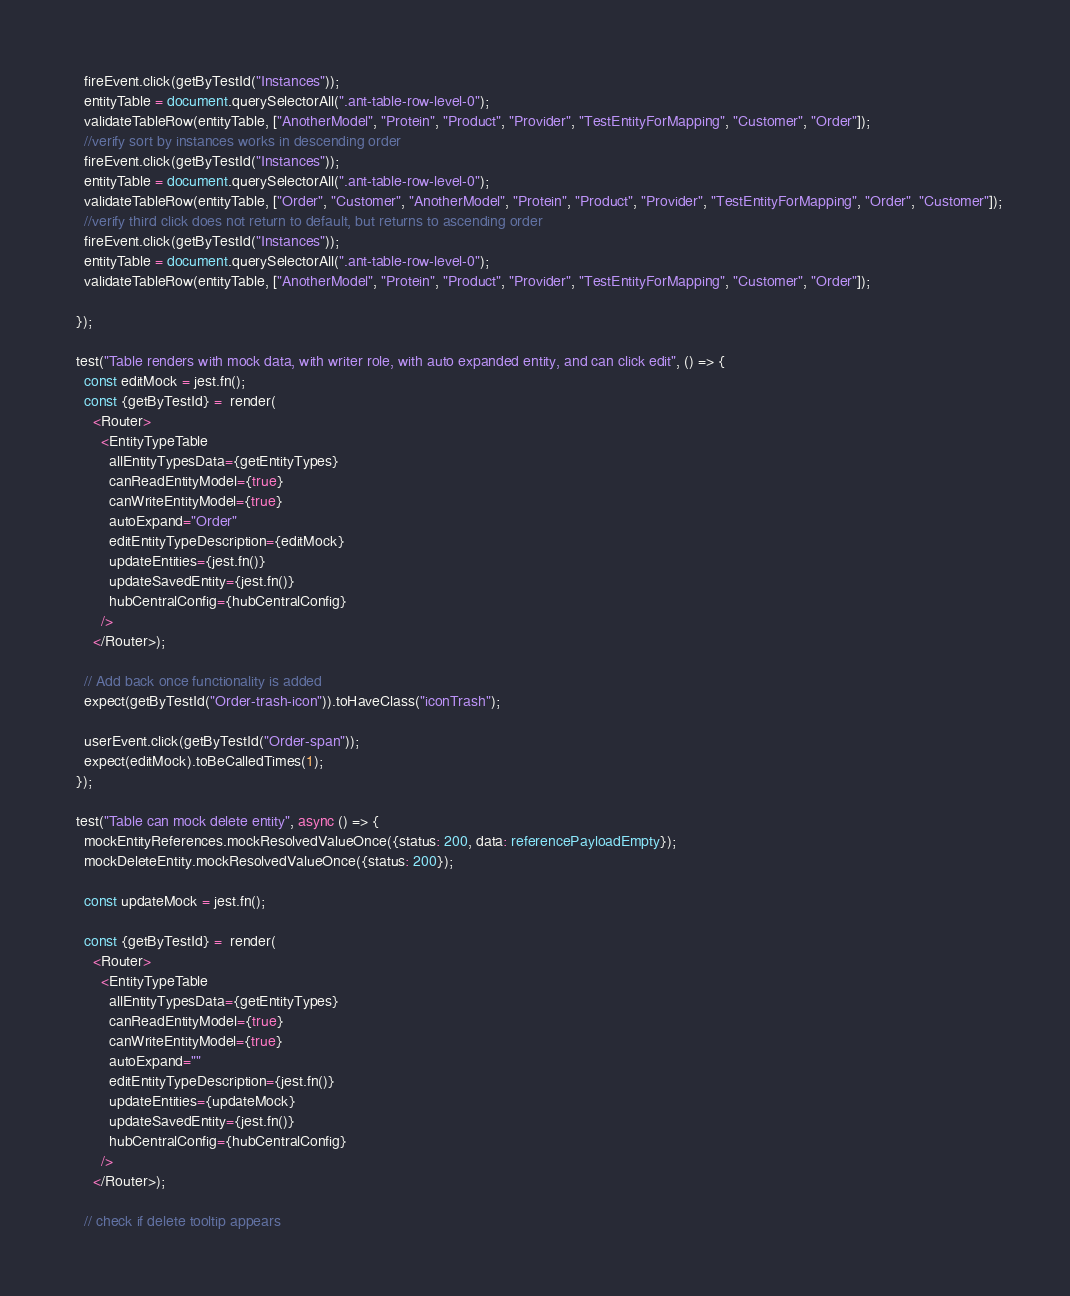<code> <loc_0><loc_0><loc_500><loc_500><_TypeScript_>    fireEvent.click(getByTestId("Instances"));
    entityTable = document.querySelectorAll(".ant-table-row-level-0");
    validateTableRow(entityTable, ["AnotherModel", "Protein", "Product", "Provider", "TestEntityForMapping", "Customer", "Order"]);
    //verify sort by instances works in descending order
    fireEvent.click(getByTestId("Instances"));
    entityTable = document.querySelectorAll(".ant-table-row-level-0");
    validateTableRow(entityTable, ["Order", "Customer", "AnotherModel", "Protein", "Product", "Provider", "TestEntityForMapping", "Order", "Customer"]);
    //verify third click does not return to default, but returns to ascending order
    fireEvent.click(getByTestId("Instances"));
    entityTable = document.querySelectorAll(".ant-table-row-level-0");
    validateTableRow(entityTable, ["AnotherModel", "Protein", "Product", "Provider", "TestEntityForMapping", "Customer", "Order"]);

  });

  test("Table renders with mock data, with writer role, with auto expanded entity, and can click edit", () => {
    const editMock = jest.fn();
    const {getByTestId} =  render(
      <Router>
        <EntityTypeTable
          allEntityTypesData={getEntityTypes}
          canReadEntityModel={true}
          canWriteEntityModel={true}
          autoExpand="Order"
          editEntityTypeDescription={editMock}
          updateEntities={jest.fn()}
          updateSavedEntity={jest.fn()}
          hubCentralConfig={hubCentralConfig}
        />
      </Router>);

    // Add back once functionality is added
    expect(getByTestId("Order-trash-icon")).toHaveClass("iconTrash");

    userEvent.click(getByTestId("Order-span"));
    expect(editMock).toBeCalledTimes(1);
  });

  test("Table can mock delete entity", async () => {
    mockEntityReferences.mockResolvedValueOnce({status: 200, data: referencePayloadEmpty});
    mockDeleteEntity.mockResolvedValueOnce({status: 200});

    const updateMock = jest.fn();

    const {getByTestId} =  render(
      <Router>
        <EntityTypeTable
          allEntityTypesData={getEntityTypes}
          canReadEntityModel={true}
          canWriteEntityModel={true}
          autoExpand=""
          editEntityTypeDescription={jest.fn()}
          updateEntities={updateMock}
          updateSavedEntity={jest.fn()}
          hubCentralConfig={hubCentralConfig}
        />
      </Router>);

    // check if delete tooltip appears</code> 